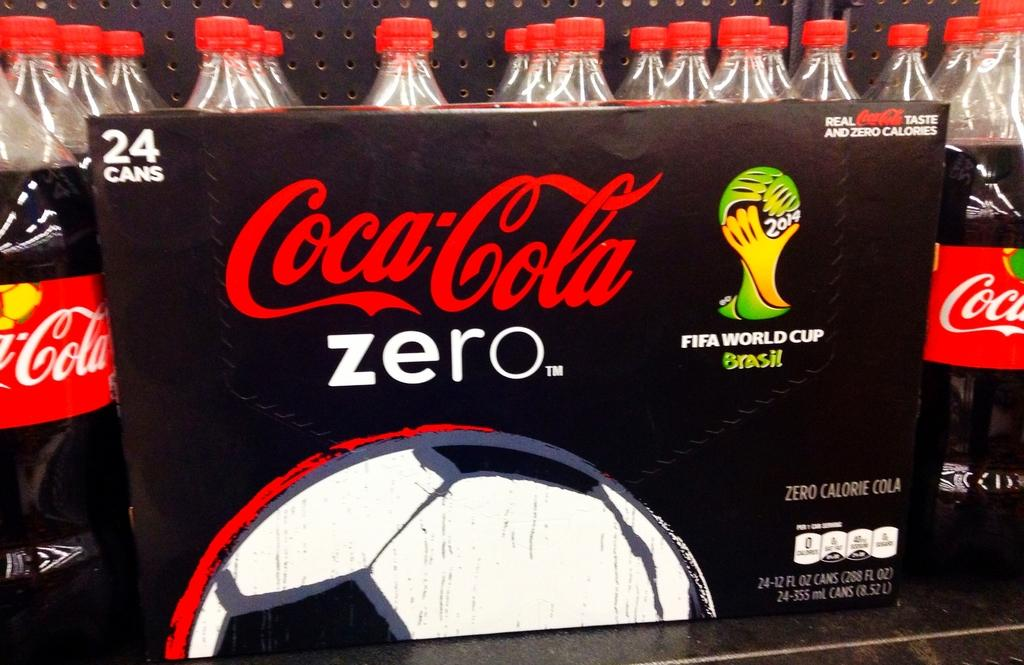What objects are visible in the image related to drinks? There are drink bottles in the image. How are the drink bottles arranged in the image? The drink bottles are placed in a rack. What is the color of the board in front of the bottles? There is a black color board in front of the bottles. What can be found on the black color board? There is text on the black color board. Can you see any snakes slithering around the drink bottles in the image? No, there are no snakes present in the image. 